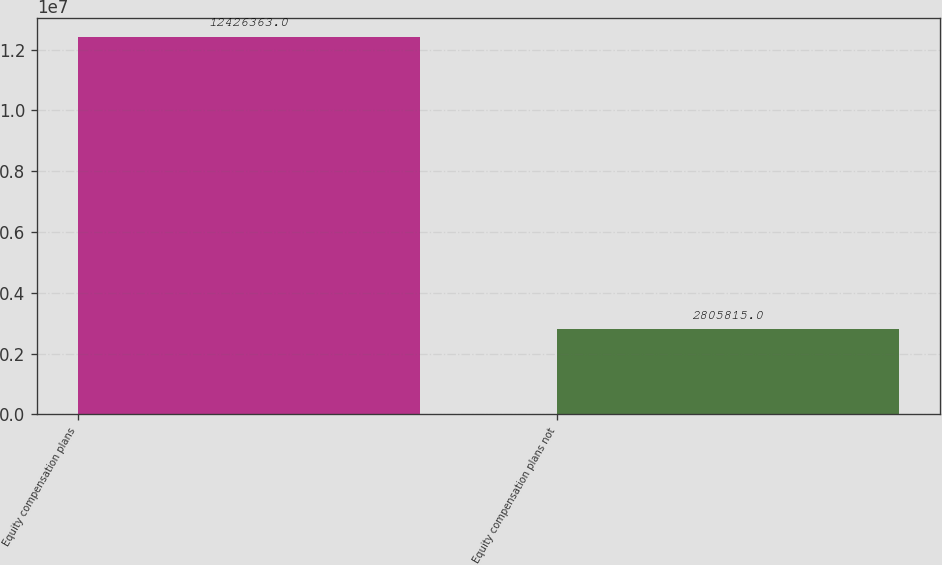Convert chart. <chart><loc_0><loc_0><loc_500><loc_500><bar_chart><fcel>Equity compensation plans<fcel>Equity compensation plans not<nl><fcel>1.24264e+07<fcel>2.80582e+06<nl></chart> 